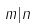<formula> <loc_0><loc_0><loc_500><loc_500>m | n</formula> 